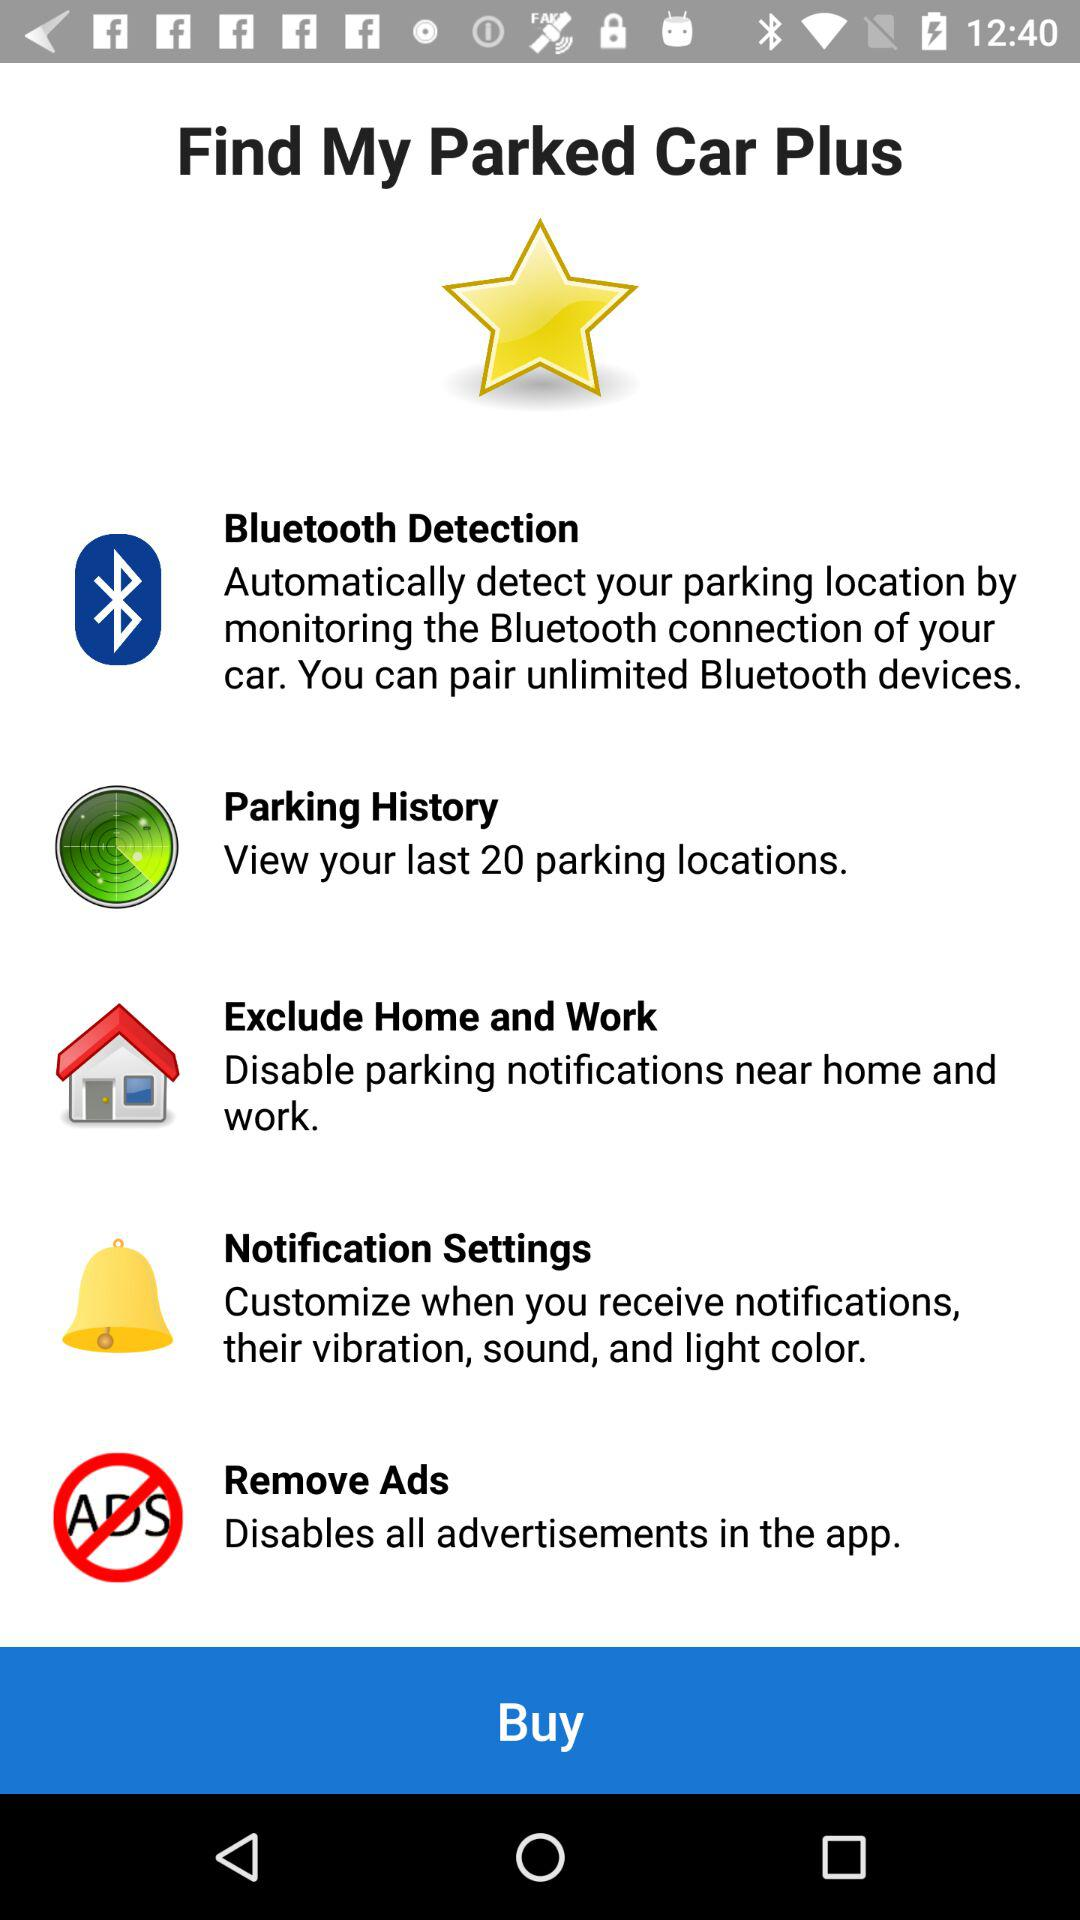How many last parking locations can be viewed in parking history? The number of last parking locations that can be viewed in parking history is 20. 